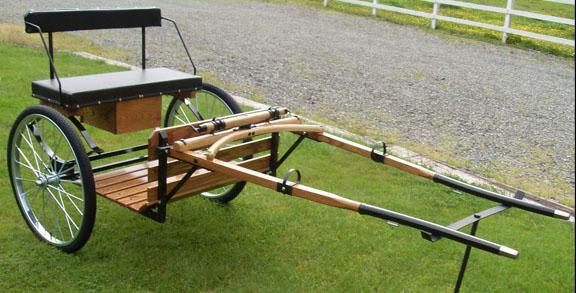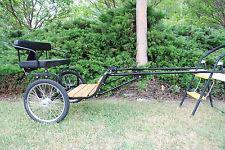The first image is the image on the left, the second image is the image on the right. Considering the images on both sides, is "The foot rest of the buggy in the left photo is made from wooden slats." valid? Answer yes or no. Yes. The first image is the image on the left, the second image is the image on the right. Evaluate the accuracy of this statement regarding the images: "At least one image features a black cart with metal grating for the foot rest.". Is it true? Answer yes or no. No. 